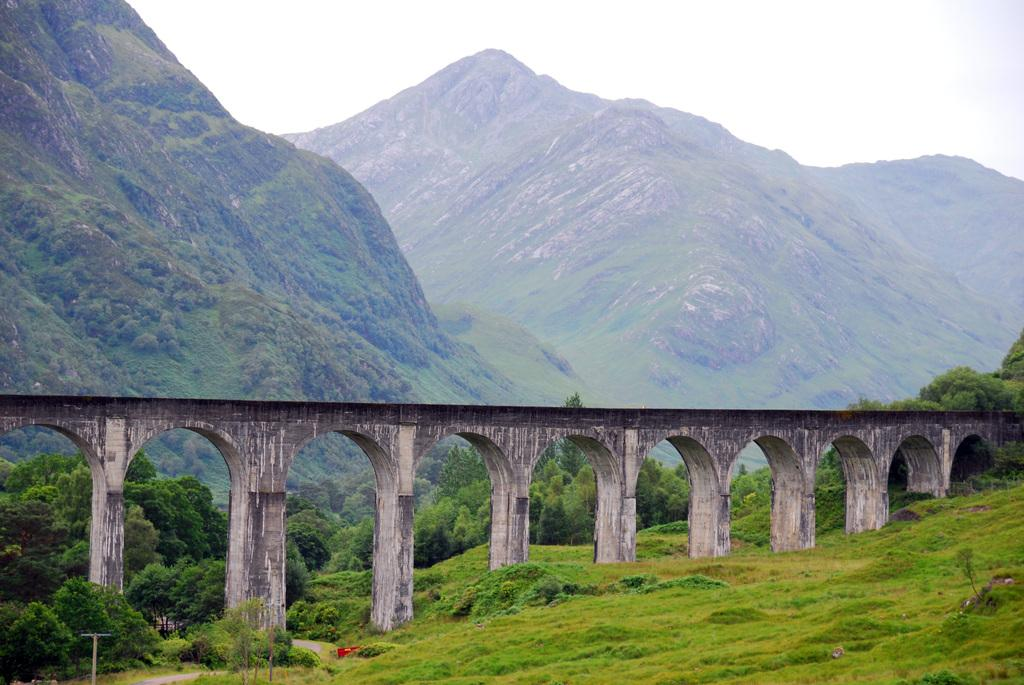What is the main structure in the center of the image? There is a bridge in the center of the image. What type of vegetation is present at the bottom of the image? There is grass and trees at the bottom of the image. What can be seen in the distance in the background of the image? There are mountains visible in the background of the image. What type of desk is visible on the bridge in the image? There is no desk present on the bridge in the image. Can you see a ship sailing near the mountains in the background of the image? There is no ship visible in the image; only the bridge, grass, trees, and mountains are present. 